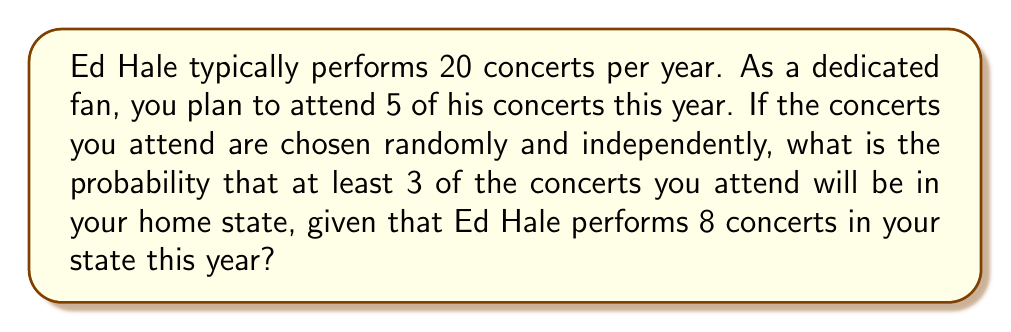Teach me how to tackle this problem. Let's approach this step-by-step:

1) First, we need to recognize this as a binomial probability problem. We're looking for the probability of at least 3 successes (concerts in your home state) out of 5 trials (concerts you attend).

2) The probability of a single concert being in your home state is:
   $p = \frac{8}{20} = 0.4$

3) We need to calculate $P(X \geq 3)$ where $X$ is the number of concerts in your home state out of the 5 you attend.

4) This is equivalent to $1 - P(X < 3)$ or $1 - [P(X=0) + P(X=1) + P(X=2)]$

5) We can use the binomial probability formula:

   $P(X=k) = \binom{n}{k} p^k (1-p)^{n-k}$

   where $n=5$, $p=0.4$, and $k$ is the number of successes.

6) Let's calculate each probability:

   $P(X=0) = \binom{5}{0} (0.4)^0 (0.6)^5 = 0.07776$
   
   $P(X=1) = \binom{5}{1} (0.4)^1 (0.6)^4 = 0.2592$
   
   $P(X=2) = \binom{5}{2} (0.4)^2 (0.6)^3 = 0.3456$

7) Now, we can calculate the probability of at least 3 concerts being in your home state:

   $P(X \geq 3) = 1 - [P(X=0) + P(X=1) + P(X=2)]$
                $= 1 - (0.07776 + 0.2592 + 0.3456)$
                $= 1 - 0.68256$
                $= 0.31744$

Therefore, the probability is approximately 0.3174 or 31.74%.
Answer: $0.3174$ or $31.74\%$ 